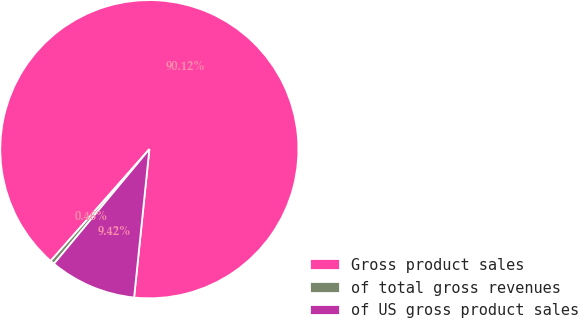<chart> <loc_0><loc_0><loc_500><loc_500><pie_chart><fcel>Gross product sales<fcel>of total gross revenues<fcel>of US gross product sales<nl><fcel>90.12%<fcel>0.46%<fcel>9.42%<nl></chart> 